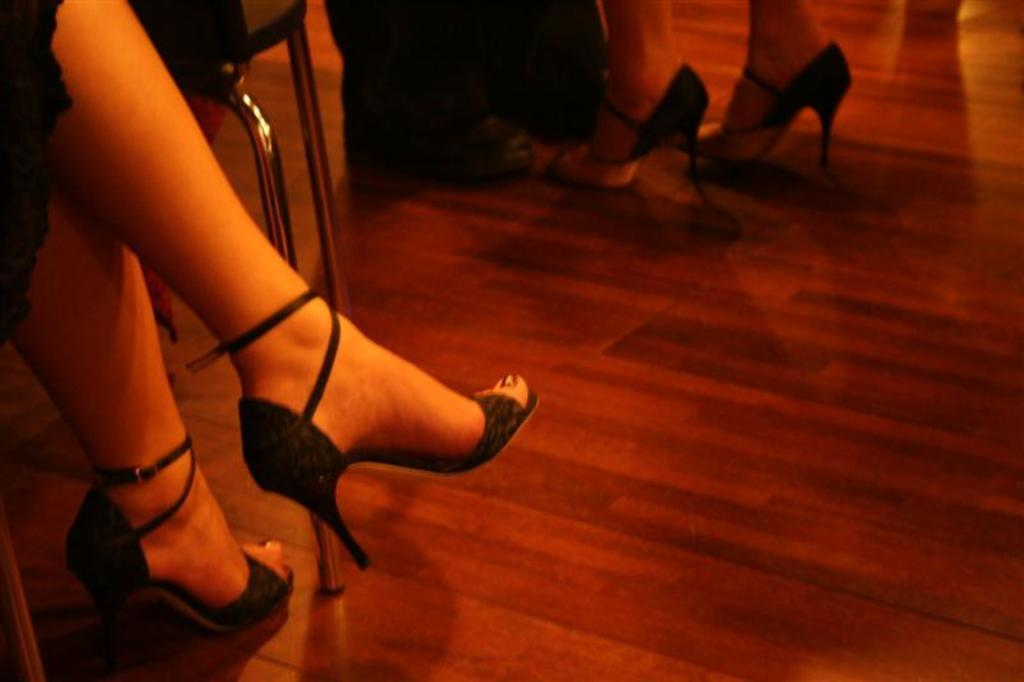How many people are in the image? There are persons in the image, but the exact number is not specified. What part of a woman's body can be seen in the image? There are woman's legs visible in the image. What type of surface is present in the image? There is a floor in the image. What type of furniture is in the image? There is a chair in the image. What type of pen is the woman holding in the image? There is no pen visible in the image. What advice might the woman's aunt give her in the image? There is no mention of an aunt or any advice-giving in the image. 